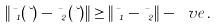<formula> <loc_0><loc_0><loc_500><loc_500>\| \mu _ { 1 } ( \lambda ) - \mu _ { 2 } ( \lambda ) \| \geq \| \mu _ { 1 } - \mu _ { 2 } \| - \ v e \, .</formula> 